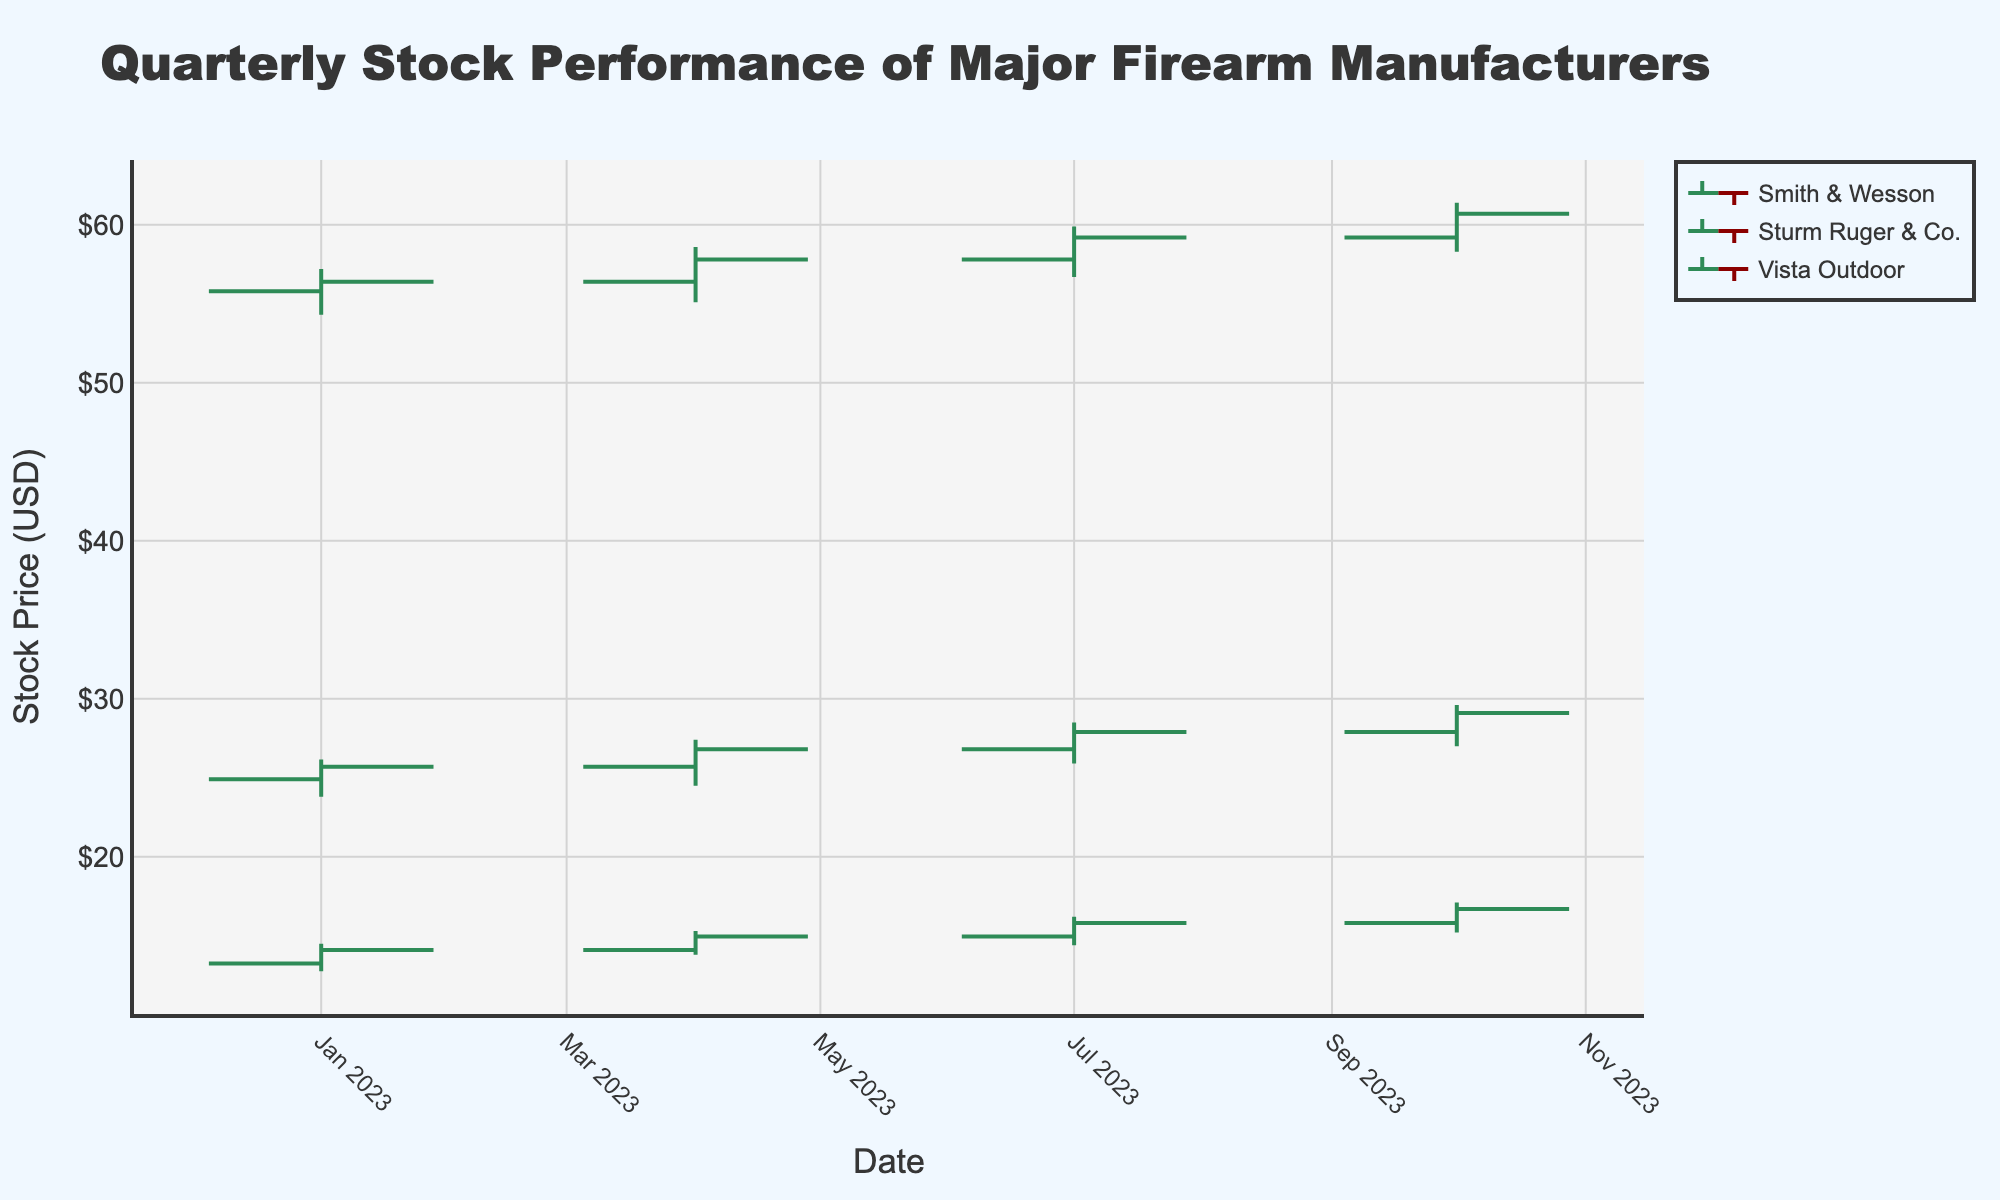Which company had the highest closing stock price in October 2023? The closing prices for October 2023 are: Smith & Wesson (16.70), Sturm Ruger & Co. (60.70), and Vista Outdoor (29.10). Comparing these, Sturm Ruger & Co. had the highest closing price.
Answer: Sturm Ruger & Co What was the overall trend for Smith & Wesson’s stock price from January to October 2023? The closing prices for Smith & Wesson over the quarters are: January (14.10), April (14.95), July (15.80), and October (16.70). The prices show a consistent upward trend.
Answer: Upward trend Which company experienced the largest range between high and low prices in any single quarter? For each company and quarter:
- Smith & Wesson, January: 14.50 - 12.75 = 1.75
- Smith & Wesson, April: 15.30 - 13.80 = 1.50
- Smith & Wesson, July: 16.20 - 14.40 = 1.80
- Smith & Wesson, October: 17.10 - 15.20 = 1.90
- Sturm Ruger & Co., January: 57.20 - 54.30 = 2.90
- Sturm Ruger & Co., April: 58.60 - 55.10 = 3.50
- Sturm Ruger & Co., July: 59.90 - 56.70 = 3.20
- Sturm Ruger & Co., October: 61.40 - 58.30 = 3.10
- Vista Outdoor, January: 26.15 - 23.80 = 2.35
- Vista Outdoor, April: 27.40 - 24.50 = 2.90
- Vista Outdoor, July: 28.50 - 25.90 = 2.60
- Vista Outdoor, October: 29.60 - 27.00 = 2.60
Sturm Ruger & Co. in April had the largest range of 3.50.
Answer: Sturm Ruger & Co., April 2023 How did Sturm Ruger & Co.'s stock price performance compare to Smith & Wesson's in July 2023? In July 2023, Sturm Ruger & Co. had an opening price of 57.80, a high of 59.90, a low of 56.70, and a closing price of 59.20. Smith & Wesson had an opening price of 14.95, a high of 16.20, a low of 14.40, and a closing price of 15.80. Sturm Ruger & Co. had both higher absolute prices and a more significant increase from opening to closing price compared to Smith & Wesson.
Answer: Sturm Ruger & Co. performed better both in absolute prices and growth What is the average closing price of Vista Outdoor across all quarters in 2023? The closing prices for Vista Outdoor in each quarter are: January (25.70), April (26.80), July (27.90), and October (29.10). The average is calculated as (25.70 + 26.80 + 27.90 + 29.10) / 4 = 27.38.
Answer: 27.38 Which quarter showed the highest closing price for each company? - Smith & Wesson: Highest closing price in October (16.70).
- Sturm Ruger & Co.: Highest closing price in October (60.70).
- Vista Outdoor: Highest closing price in October (29.10).
All companies had their highest closing prices in October 2023.
Answer: October 2023 for all companies During which quarter did Vista Outdoor see the largest increase in its closing price from the previous quarter? The closing prices for Vista Outdoor by quarter are: January (25.70), April (26.80), July (27.90), and October (29.10). The increases are: 
- January to April: 26.80 - 25.70 = 1.10
- April to July: 27.90 - 26.80 = 1.10
- July to October: 29.10 - 27.90 = 1.20
July to October had the largest increase.
Answer: July to October How does the April 2023 high price for Smith & Wesson compare to its October 2023 high price? Smith & Wesson's high prices for April 2023 and October 2023 are 15.30 and 17.10, respectively. The October high is significantly higher than the April high.
Answer: October high is higher 